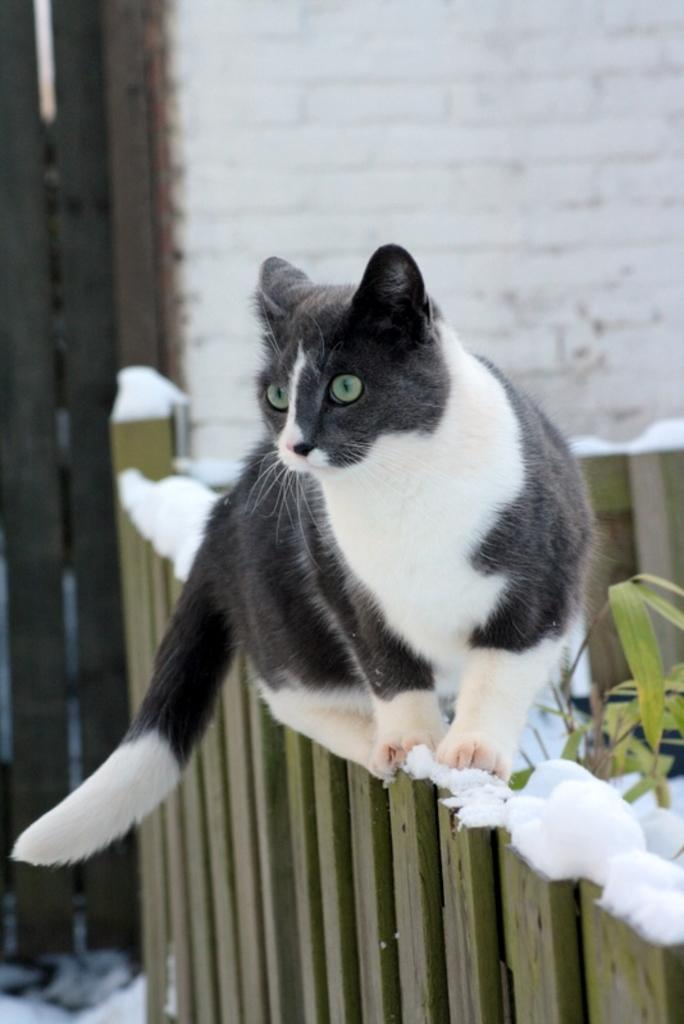What animal can be seen in the image? There is a cat in the image. Where is the cat sitting? The cat is sitting on a fence. What is the condition of the fence? There is snow on the fence. What structures can be seen in the backdrop of the image? There is a door and a wall in the backdrop of the image. What team does the cat belong to in the image? The image does not depict any teams or affiliations, so it cannot be determined if the cat belongs to a team. 